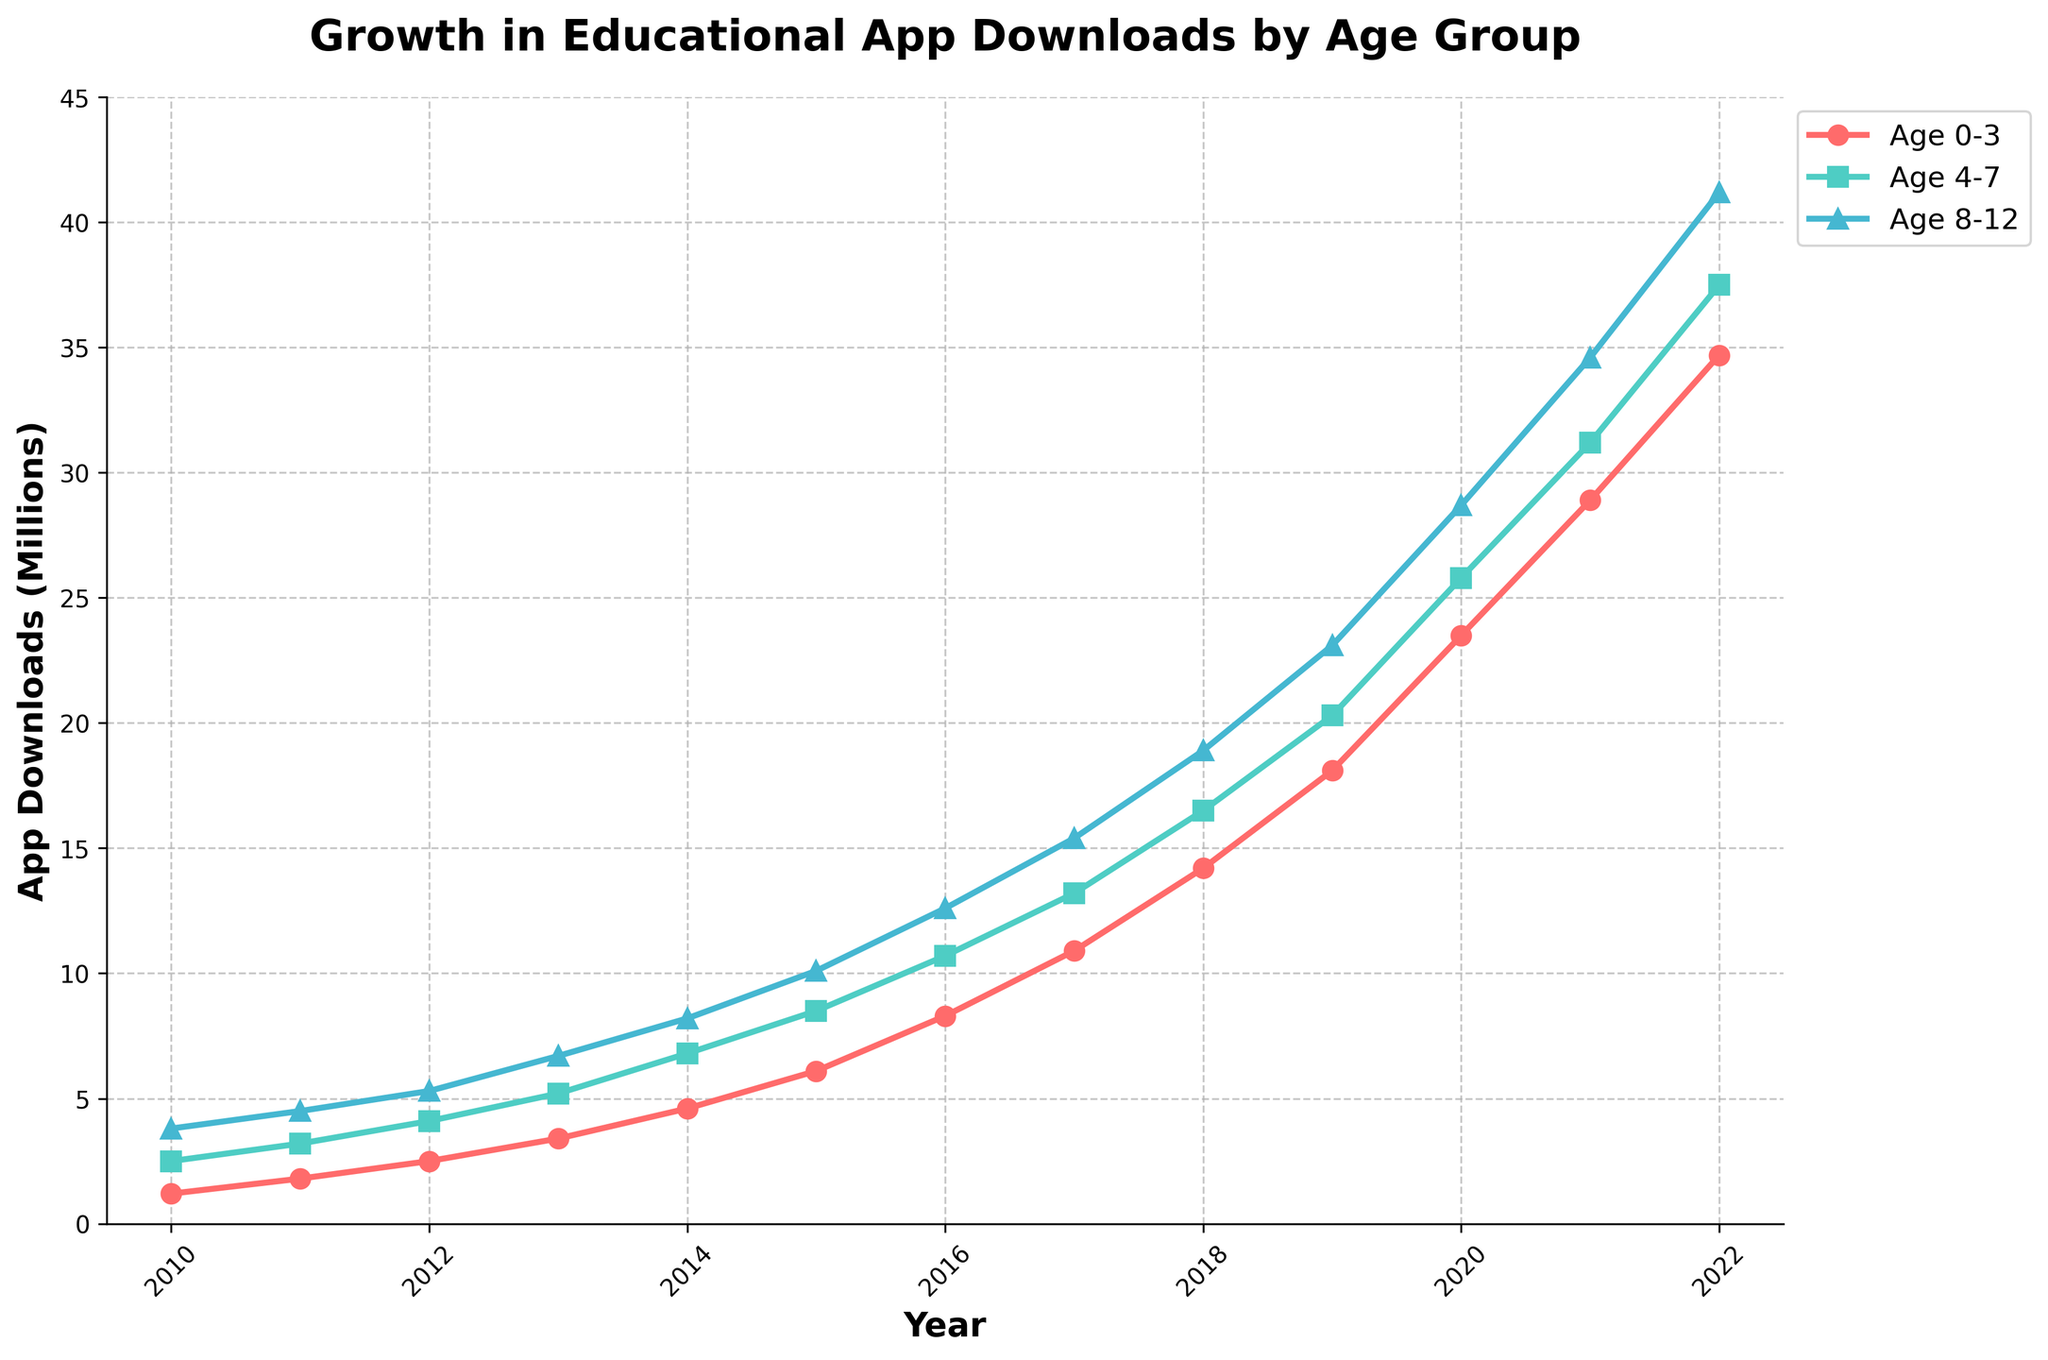What is the overall trend in educational app downloads for all age groups from 2010 to 2022? The overall trend in educational app downloads for all age groups from 2010 to 2022 is consistently upward. Each age group shows a steady increase in the number of downloads over this period.
Answer: Upward trend Which age group saw the highest increase in app downloads from 2010 to 2022? To determine which age group saw the highest increase, subtract the 2010 value from the 2022 value for each age group: Age 0-3: 34.7 - 1.2 = 33.5 million, Age 4-7: 37.5 - 2.5 = 35 million, Age 8-12: 41.2 - 3.8 = 37.4 million.
Answer: Age 8-12 How many more downloads were there for the 8-12 age group than the 4-7 age group in 2019? To find the difference in downloads between the 8-12 and 4-7 age groups in 2019, subtract the downloads for the 4-7 age group from the 8-12 age group: 23.1 - 20.3 = 2.8 million.
Answer: 2.8 million In which year did the educational app downloads for the 0-3 age group first exceed 10 million? Identify the first year where the data value for Age 0-3 exceeds 10 million. In 2017, the downloads for Age 0-3 were 10.9 million.
Answer: 2017 What's the average number of downloads for the age 4-7 group from 2010 to 2022? Sum all the values for Age 4-7 and divide by the number of years: (2.5 + 3.2 + 4.1 + 5.2 + 6.8 + 8.5 + 10.7 + 13.2 + 16.5 + 20.3 + 25.8 + 31.2 + 37.5) / 13 = 14.7 million.
Answer: 14.7 million Between which consecutive years did the 4-7 age group see the largest increase in downloads? Calculate the year-over-year increases: from 2019 to 2020 is 25.8 - 20.3 = 5.5 million. This is the largest increase between any two consecutive years for the 4-7 age group.
Answer: 2019 to 2020 Is there any point where the downloads for the Age 0-3 group exceeded the combined downloads for the Age 4-7 and Age 8-12 groups? Check if the value for Age 0-3 ever exceeds the sum of Age 4-7 and Age 8-12 for any year. It never happens; the combined value is always higher.
Answer: No Which age group had the steepest increase in app downloads as seen from the slope of the line in the plot? The steepness of the increase is reflected in the gradient of the lines. Age 8-12 shows the steepest slope, indicating the largest rate of change in app downloads over the years.
Answer: Age 8-12 